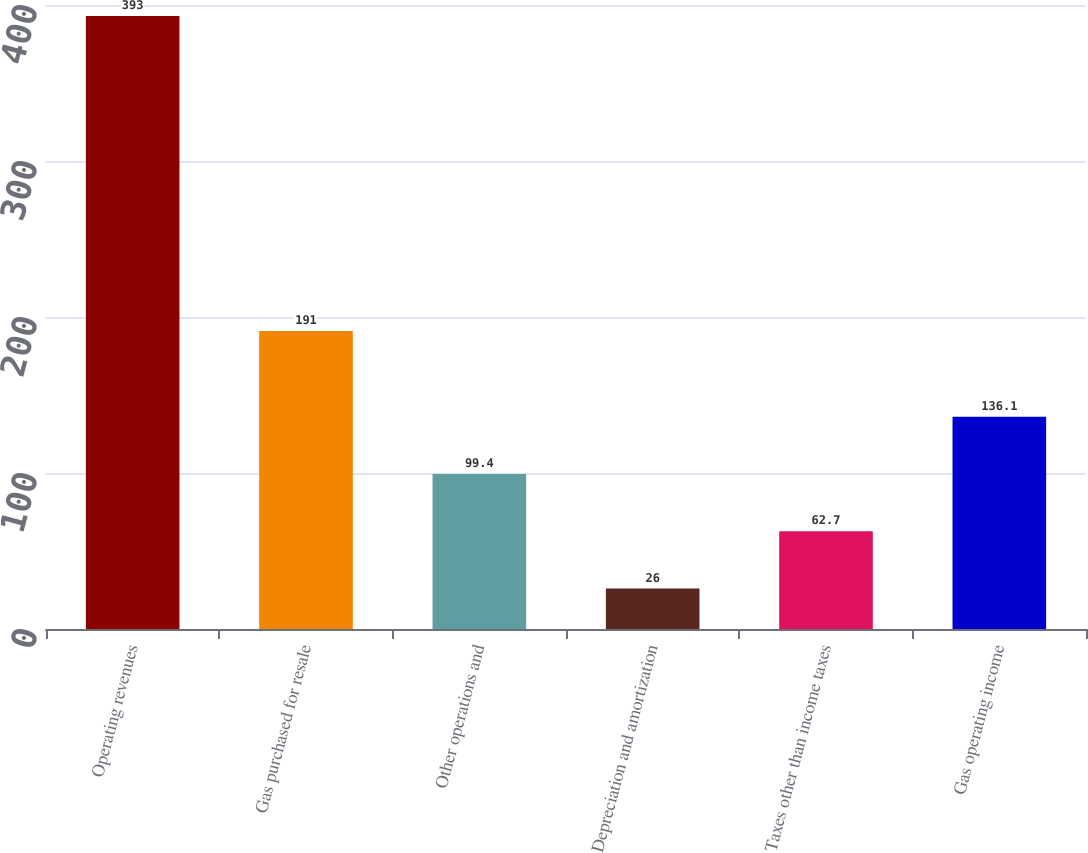Convert chart. <chart><loc_0><loc_0><loc_500><loc_500><bar_chart><fcel>Operating revenues<fcel>Gas purchased for resale<fcel>Other operations and<fcel>Depreciation and amortization<fcel>Taxes other than income taxes<fcel>Gas operating income<nl><fcel>393<fcel>191<fcel>99.4<fcel>26<fcel>62.7<fcel>136.1<nl></chart> 